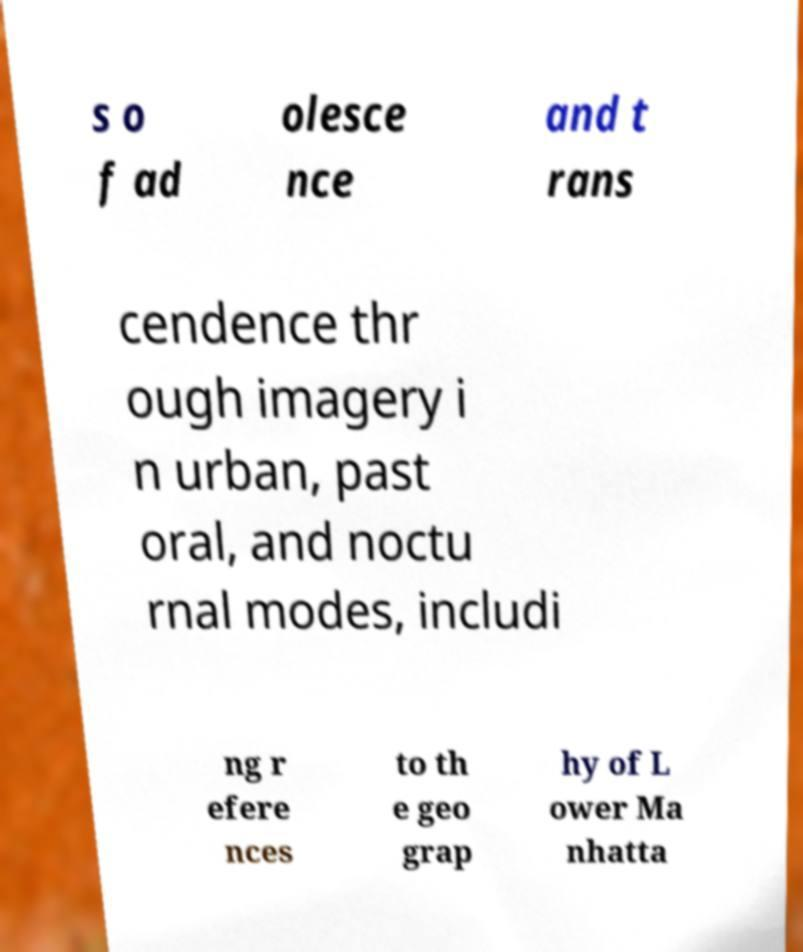Could you assist in decoding the text presented in this image and type it out clearly? s o f ad olesce nce and t rans cendence thr ough imagery i n urban, past oral, and noctu rnal modes, includi ng r efere nces to th e geo grap hy of L ower Ma nhatta 